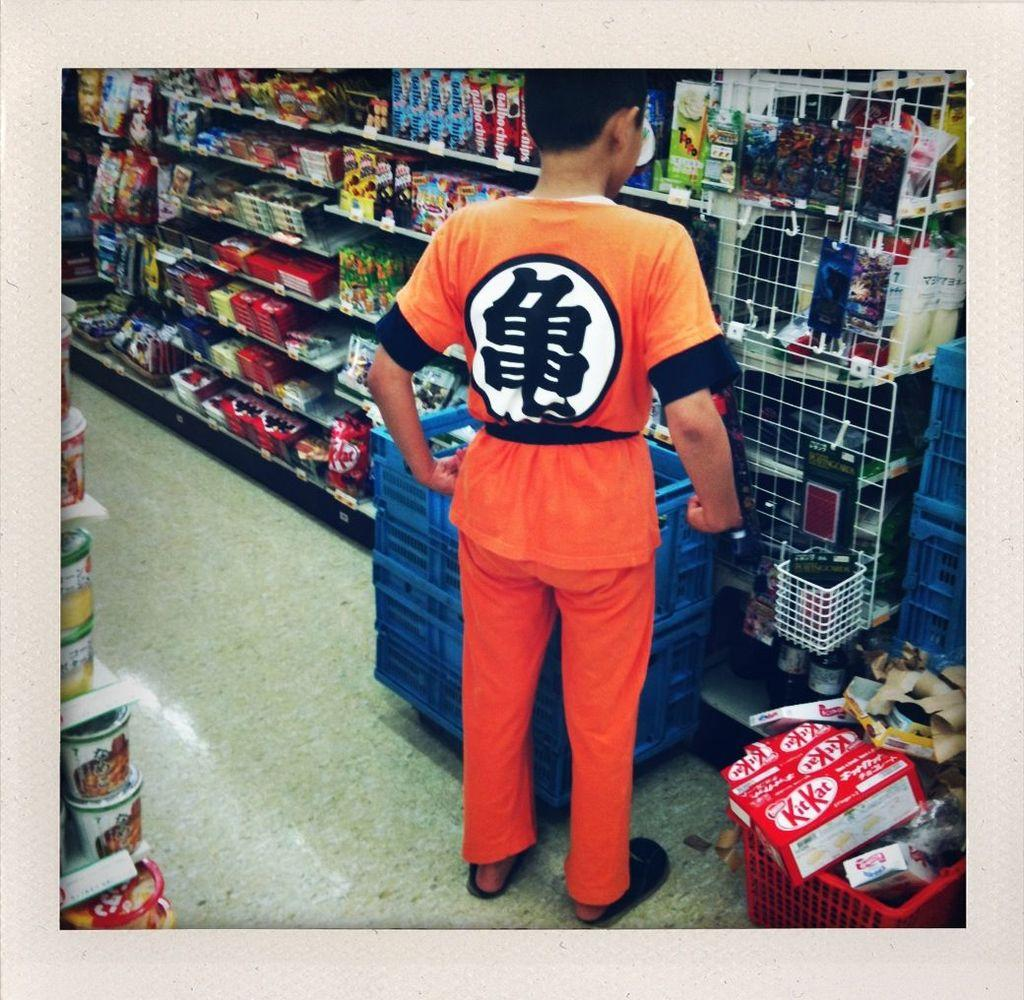<image>
Write a terse but informative summary of the picture. A young man in an orange karate suit stands next to a large box of Kit Kats. 